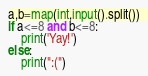<code> <loc_0><loc_0><loc_500><loc_500><_Python_>a,b=map(int,input().split())
if a<=8 and b<=8:
    print('Yay!')
else:
    print(":(")
</code> 